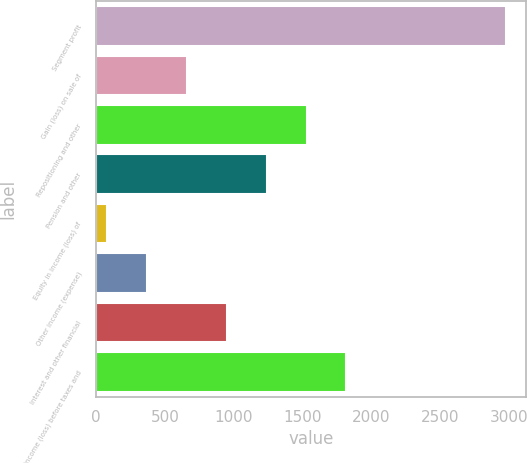Convert chart. <chart><loc_0><loc_0><loc_500><loc_500><bar_chart><fcel>Segment profit<fcel>Gain (loss) on sale of<fcel>Repositioning and other<fcel>Pension and other<fcel>Equity in income (loss) of<fcel>Other income (expense)<fcel>Interest and other financial<fcel>Income (loss) before taxes and<nl><fcel>2974<fcel>660.4<fcel>1528<fcel>1238.8<fcel>82<fcel>371.2<fcel>949.6<fcel>1817.2<nl></chart> 